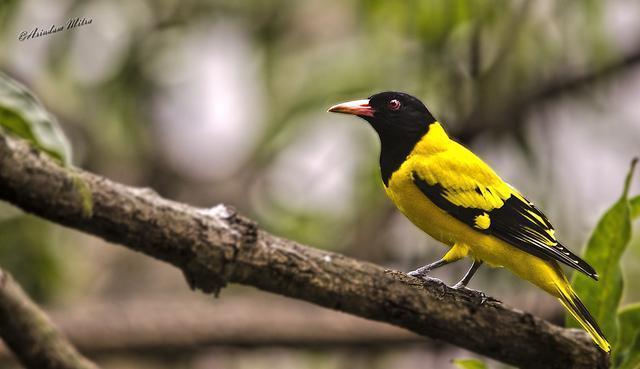How many birds are in the background?
Give a very brief answer. 0. 